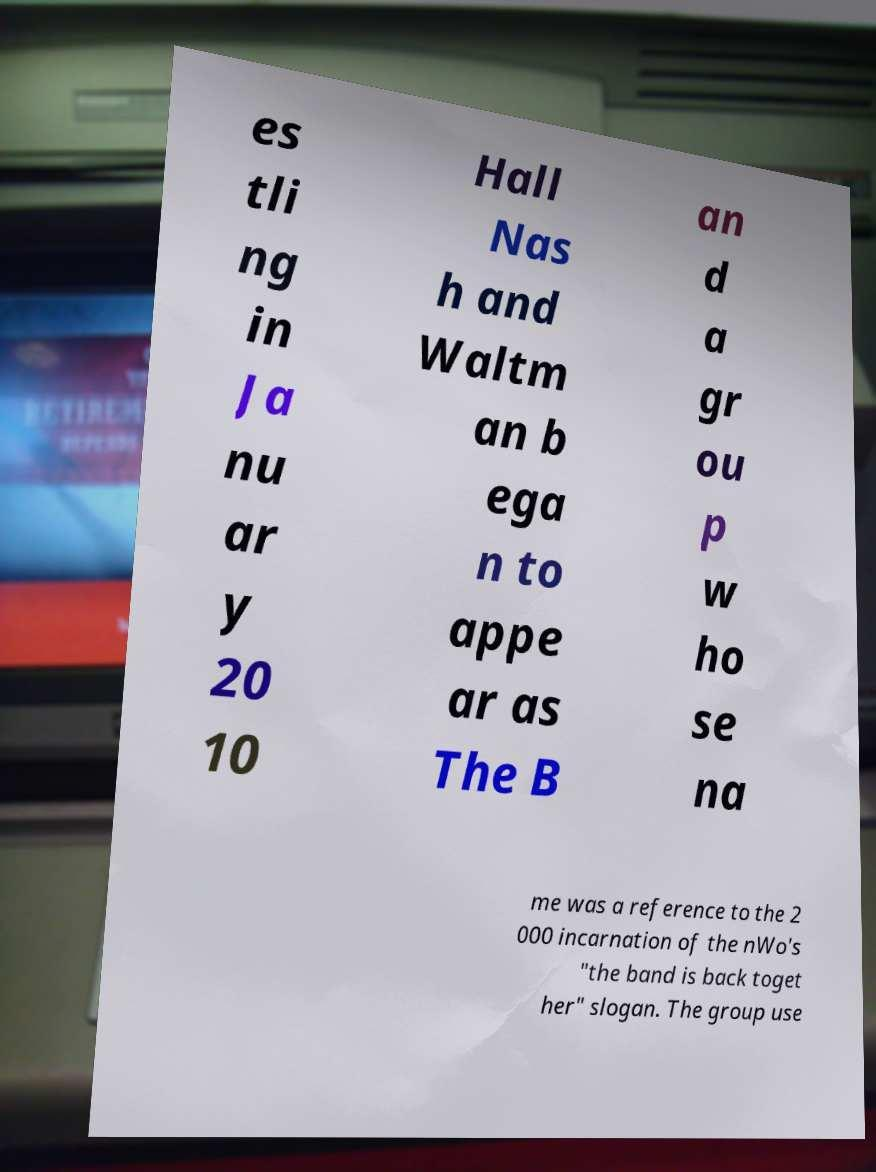What messages or text are displayed in this image? I need them in a readable, typed format. es tli ng in Ja nu ar y 20 10 Hall Nas h and Waltm an b ega n to appe ar as The B an d a gr ou p w ho se na me was a reference to the 2 000 incarnation of the nWo's "the band is back toget her" slogan. The group use 